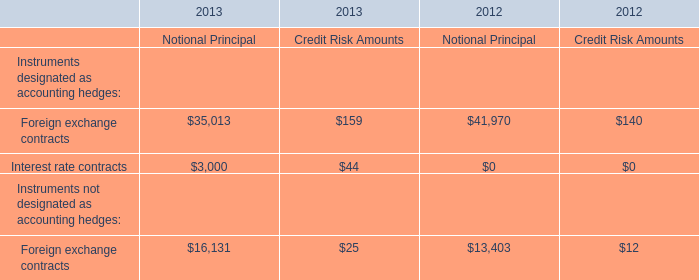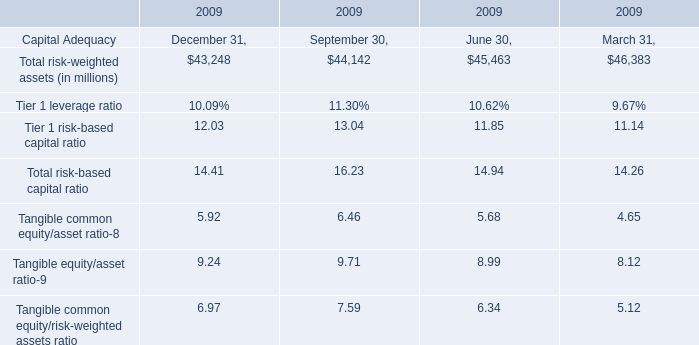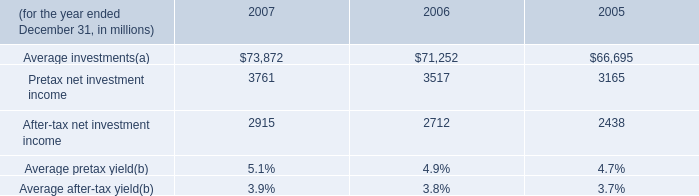What is the Total risk-based capital ratio at September 30, 2009? (in %) 
Answer: 16.23. 